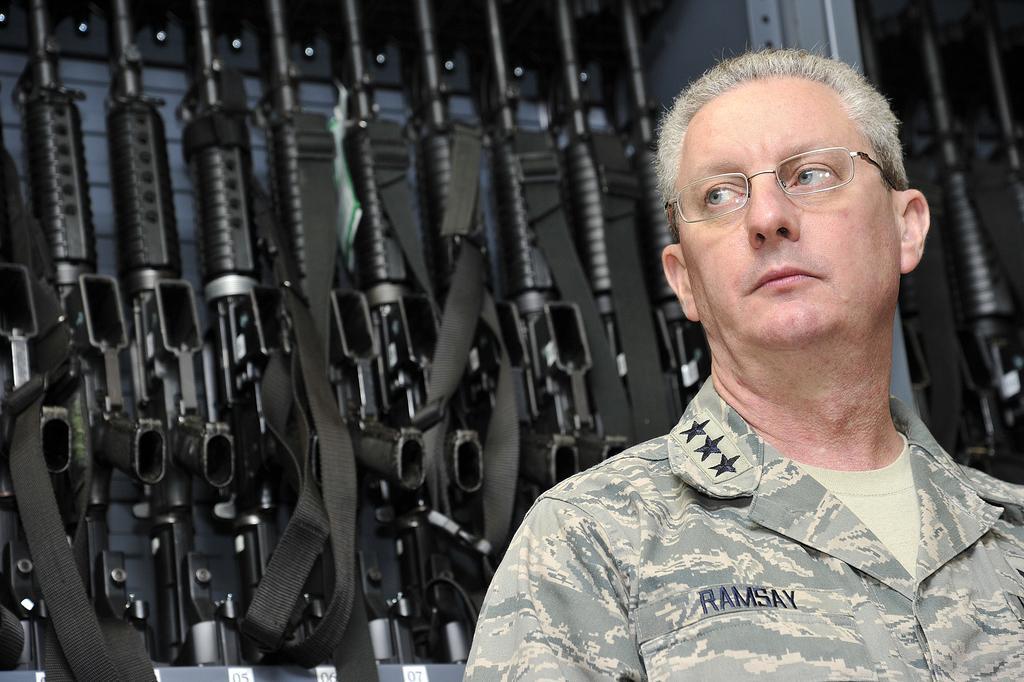In one or two sentences, can you explain what this image depicts? In this image I can see a person wearing military dress, background I can see few guns in black color. 